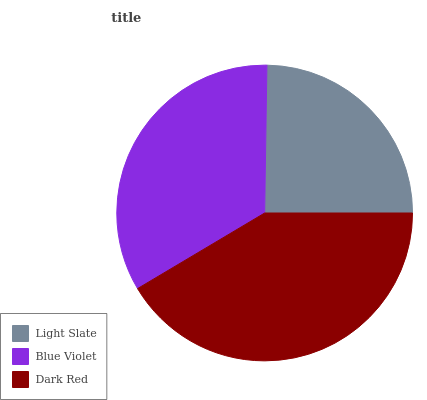Is Light Slate the minimum?
Answer yes or no. Yes. Is Dark Red the maximum?
Answer yes or no. Yes. Is Blue Violet the minimum?
Answer yes or no. No. Is Blue Violet the maximum?
Answer yes or no. No. Is Blue Violet greater than Light Slate?
Answer yes or no. Yes. Is Light Slate less than Blue Violet?
Answer yes or no. Yes. Is Light Slate greater than Blue Violet?
Answer yes or no. No. Is Blue Violet less than Light Slate?
Answer yes or no. No. Is Blue Violet the high median?
Answer yes or no. Yes. Is Blue Violet the low median?
Answer yes or no. Yes. Is Dark Red the high median?
Answer yes or no. No. Is Light Slate the low median?
Answer yes or no. No. 